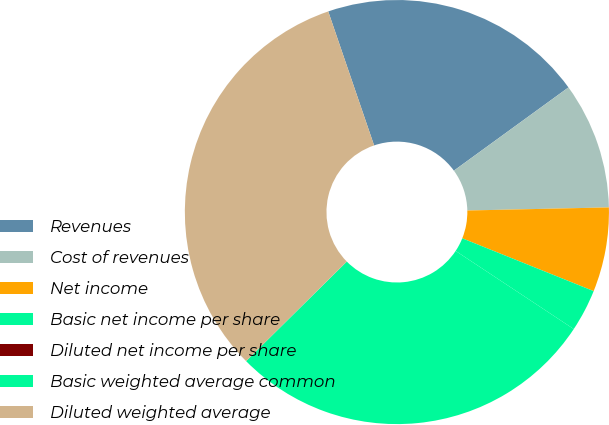<chart> <loc_0><loc_0><loc_500><loc_500><pie_chart><fcel>Revenues<fcel>Cost of revenues<fcel>Net income<fcel>Basic net income per share<fcel>Diluted net income per share<fcel>Basic weighted average common<fcel>Diluted weighted average<nl><fcel>20.25%<fcel>9.65%<fcel>6.43%<fcel>3.22%<fcel>0.0%<fcel>28.29%<fcel>32.16%<nl></chart> 